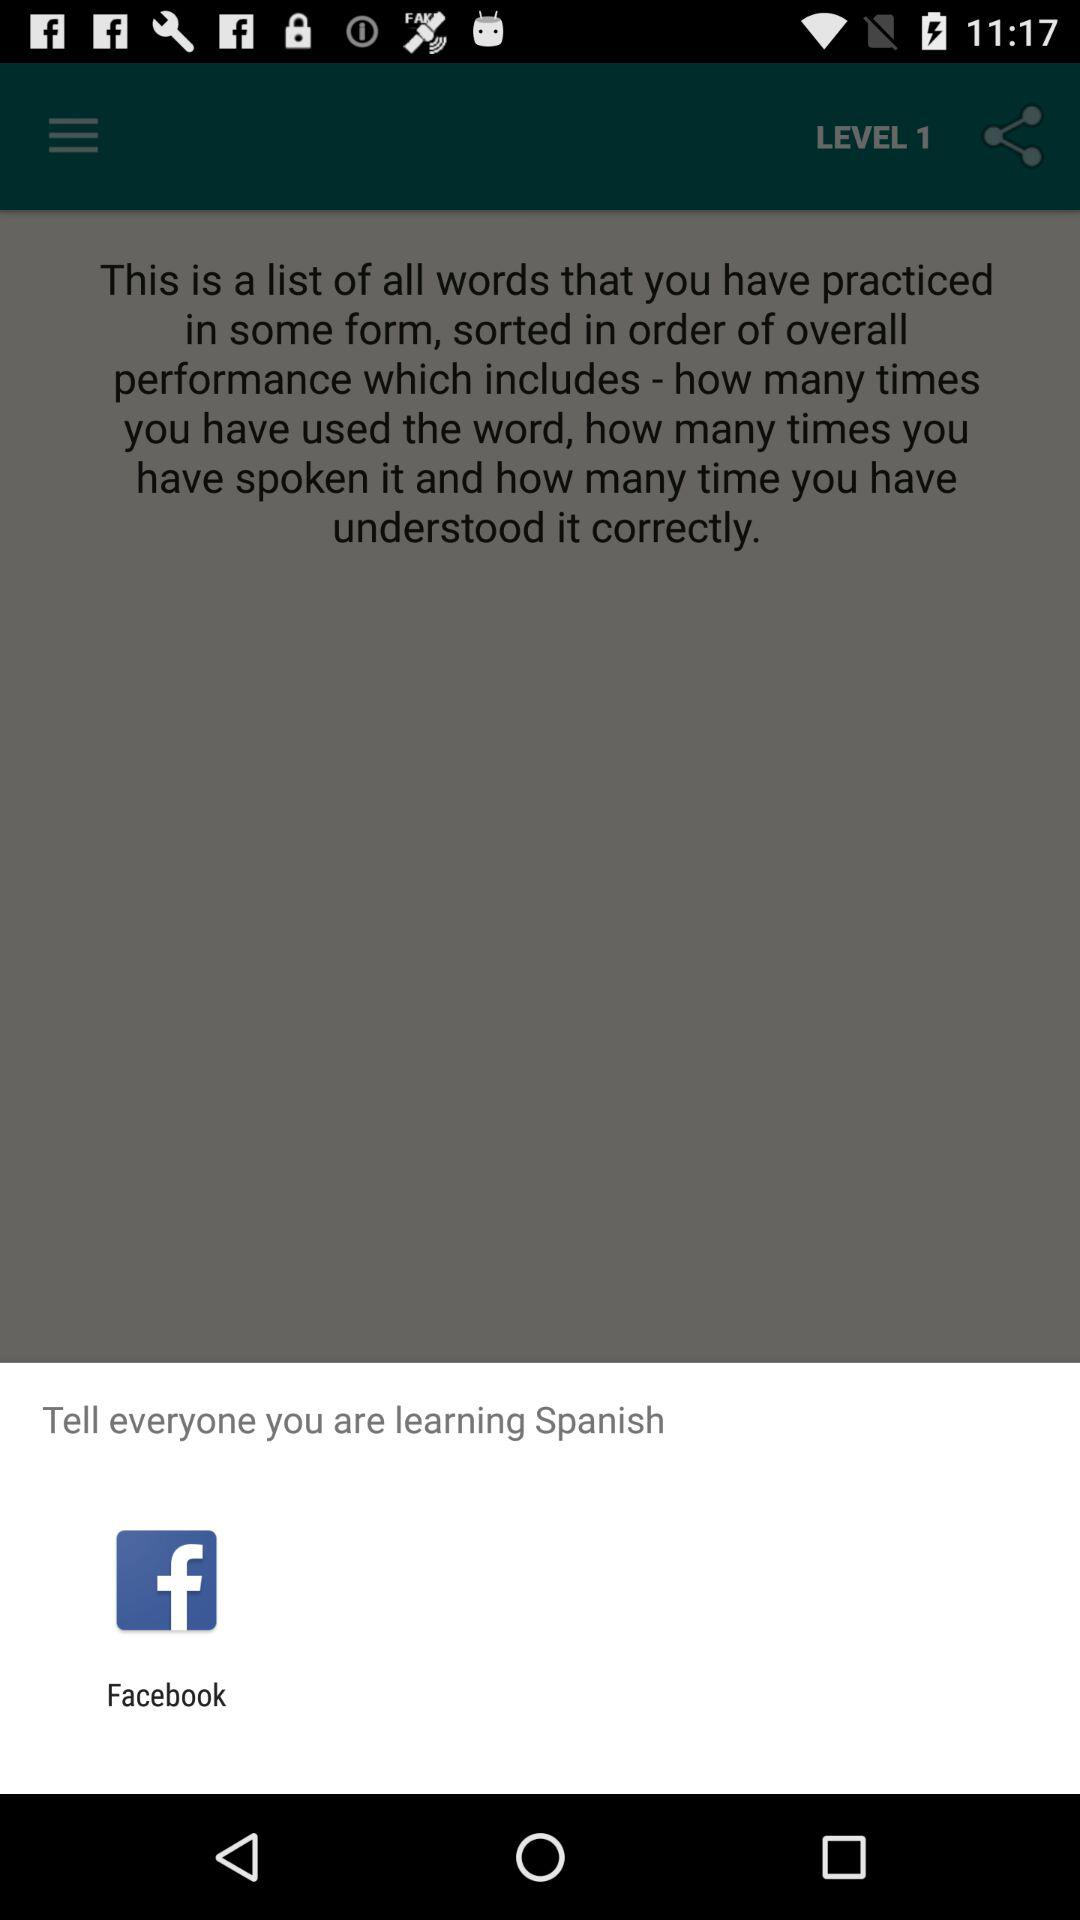What is the different medium to tell everyone? The medium is "Facebook". 